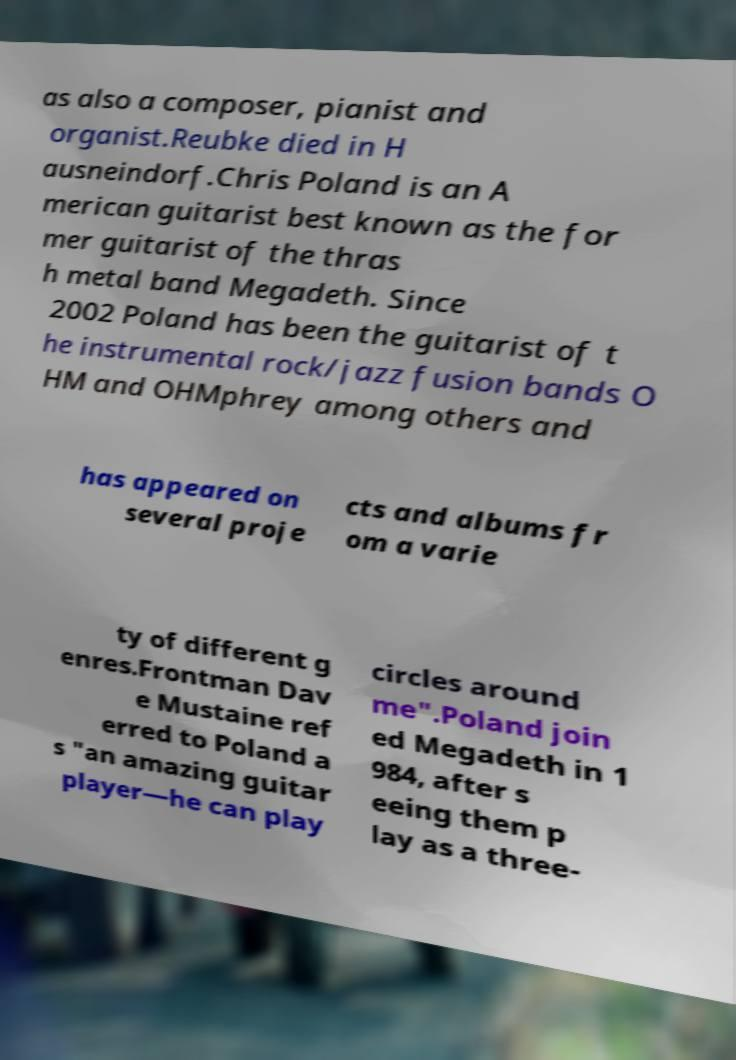Could you assist in decoding the text presented in this image and type it out clearly? as also a composer, pianist and organist.Reubke died in H ausneindorf.Chris Poland is an A merican guitarist best known as the for mer guitarist of the thras h metal band Megadeth. Since 2002 Poland has been the guitarist of t he instrumental rock/jazz fusion bands O HM and OHMphrey among others and has appeared on several proje cts and albums fr om a varie ty of different g enres.Frontman Dav e Mustaine ref erred to Poland a s "an amazing guitar player—he can play circles around me".Poland join ed Megadeth in 1 984, after s eeing them p lay as a three- 